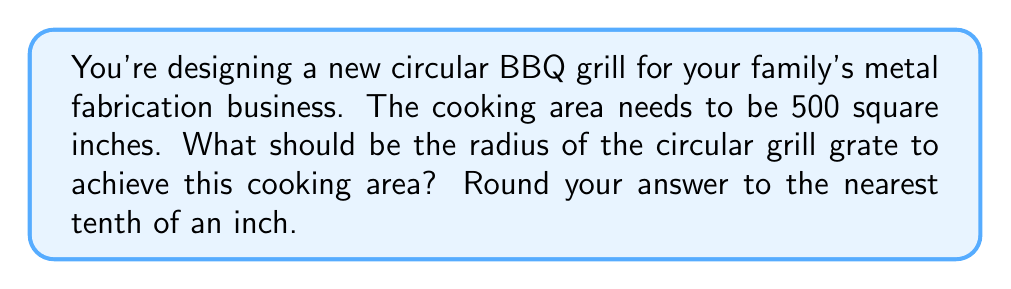Provide a solution to this math problem. Let's approach this step-by-step:

1) The area of a circle is given by the formula:

   $$A = \pi r^2$$

   Where $A$ is the area and $r$ is the radius.

2) We're given that the cooking area (A) needs to be 500 square inches. Let's substitute this into our formula:

   $$500 = \pi r^2$$

3) To solve for $r$, we need to divide both sides by $\pi$ and then take the square root:

   $$\frac{500}{\pi} = r^2$$

   $$r = \sqrt{\frac{500}{\pi}}$$

4) Let's calculate this:

   $$r = \sqrt{\frac{500}{3.14159...}} \approx 12.6157$$

5) Rounding to the nearest tenth of an inch:

   $$r \approx 12.6\ \text{inches}$$

This radius will give us a cooking area of approximately 500 square inches.

[asy]
import geometry;

size(200);
draw(circle((0,0),126), linewidth(1));
draw((0,0)--(126,0), arrow=Arrow(TeXHead));
label("12.6\"", (63,5), N);
label("r", (63,-5), S);
[/asy]
Answer: The radius of the circular grill grate should be 12.6 inches. 